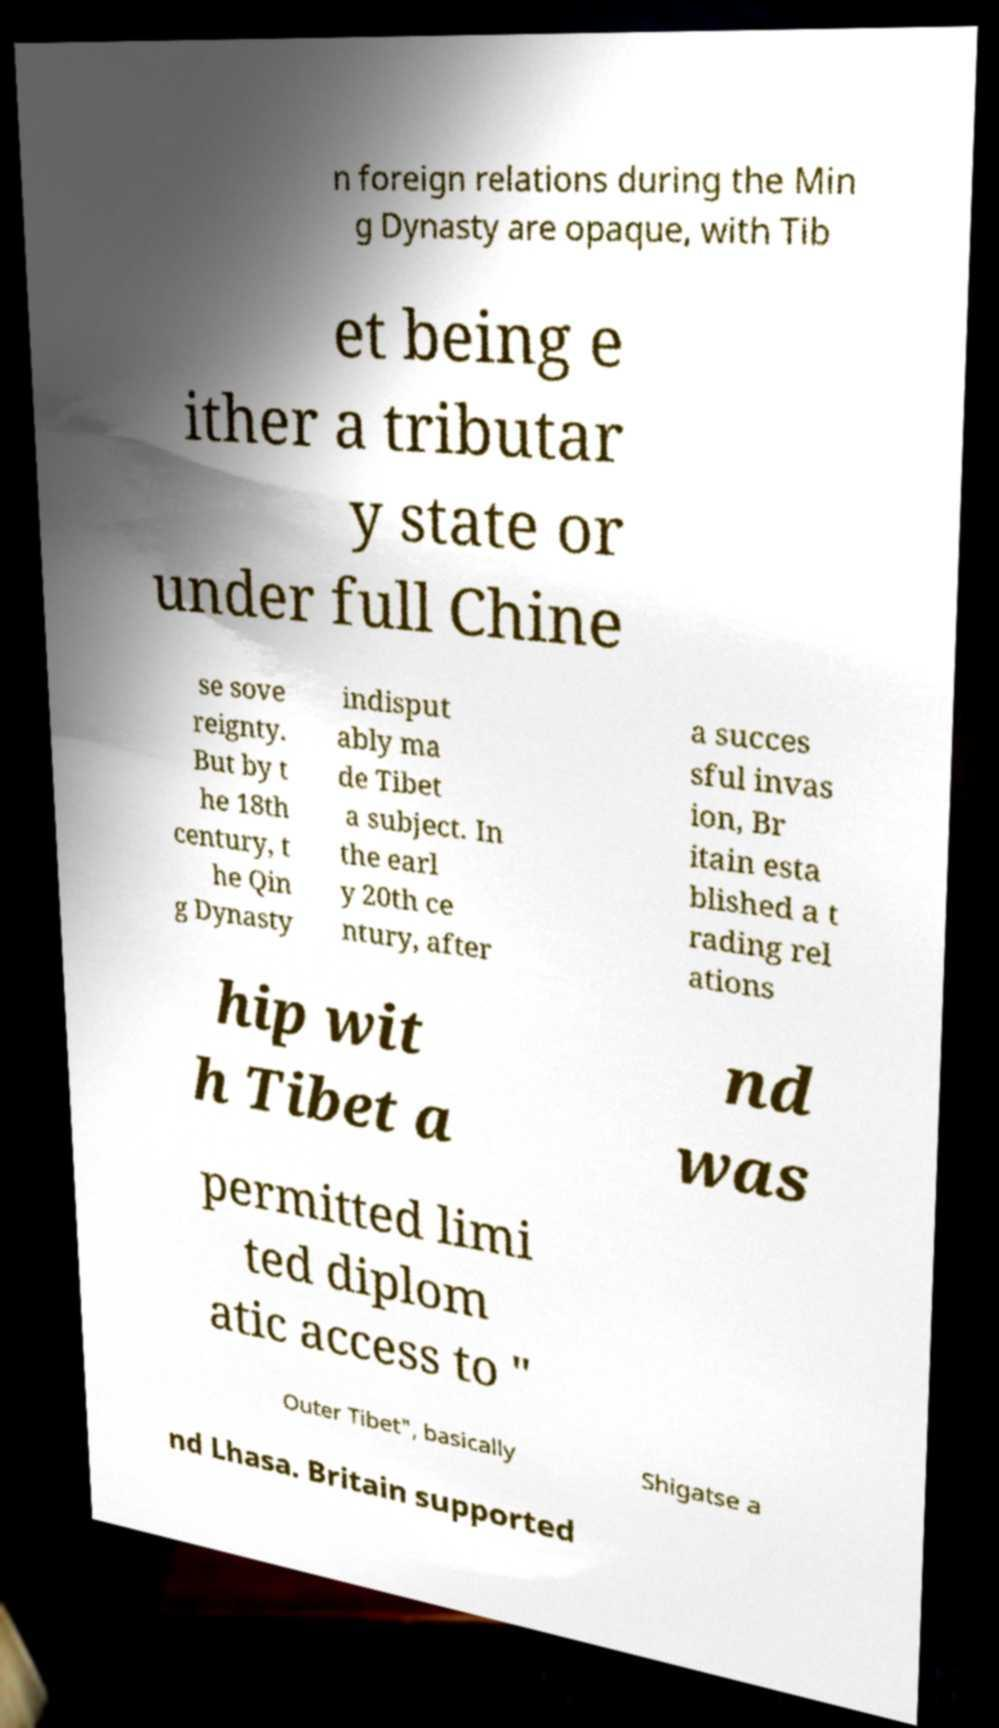Please read and relay the text visible in this image. What does it say? n foreign relations during the Min g Dynasty are opaque, with Tib et being e ither a tributar y state or under full Chine se sove reignty. But by t he 18th century, t he Qin g Dynasty indisput ably ma de Tibet a subject. In the earl y 20th ce ntury, after a succes sful invas ion, Br itain esta blished a t rading rel ations hip wit h Tibet a nd was permitted limi ted diplom atic access to " Outer Tibet", basically Shigatse a nd Lhasa. Britain supported 